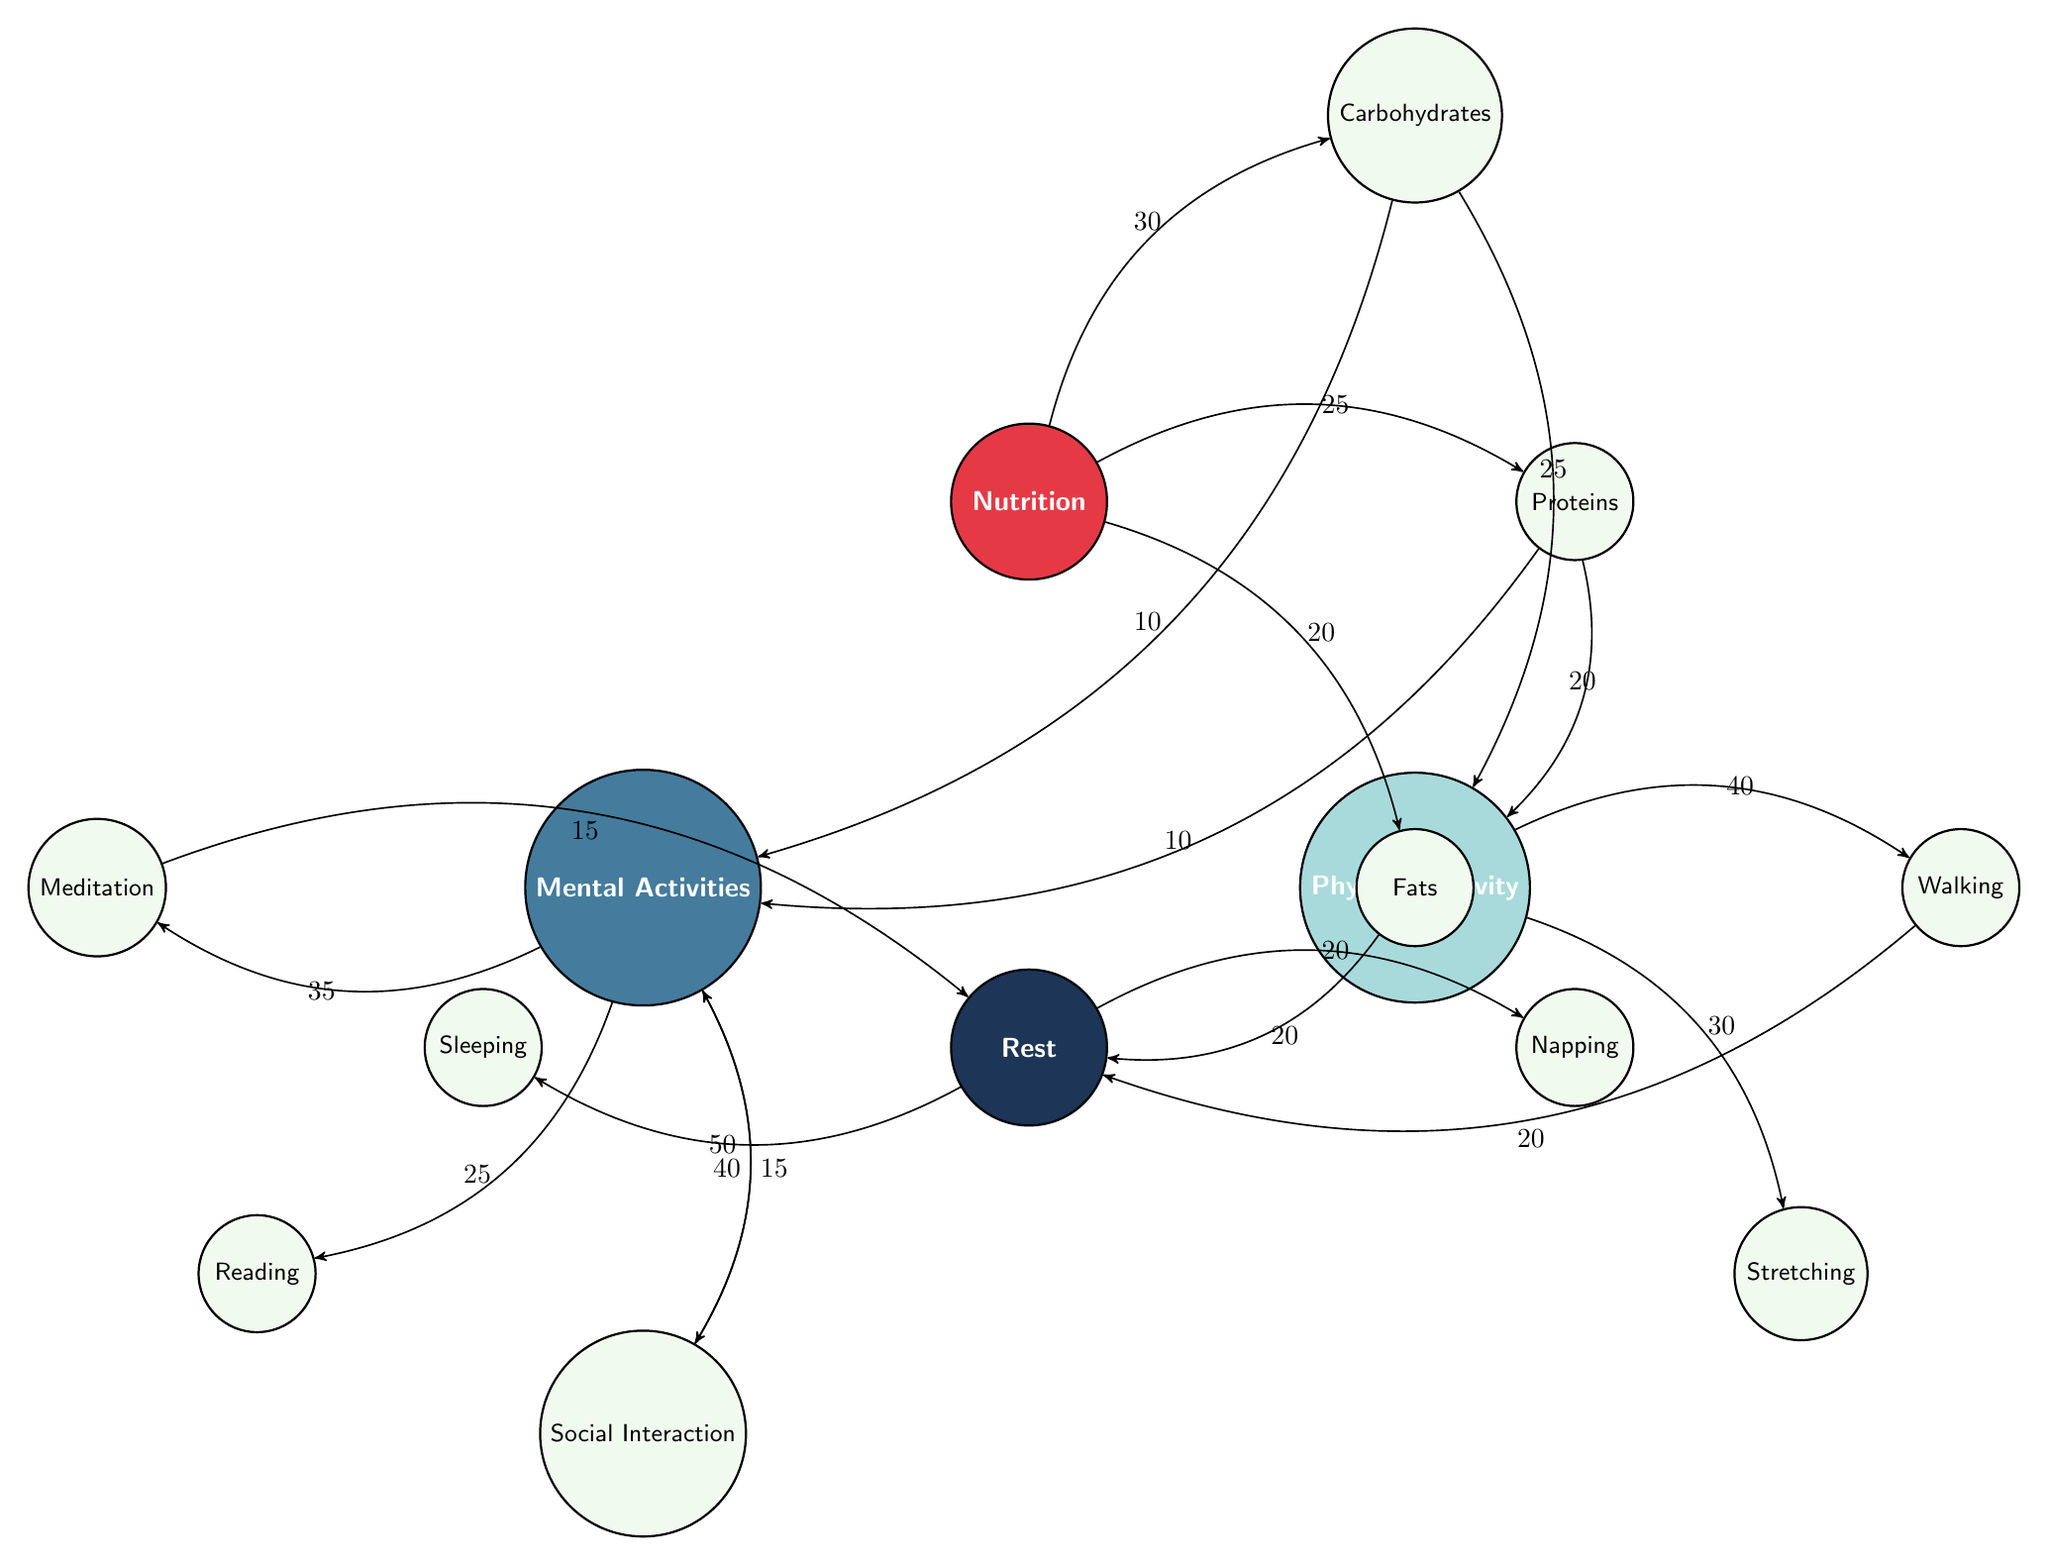What is the value connecting Nutrition to Carbohydrates? The diagram shows an edge between the Nutrition node and the Carbohydrates node, with a value of 30 labeled on the edge.
Answer: 30 How many nodes are in the diagram? By counting the nodes listed on the diagram, there are a total of 12 nodes: Nutrition, Physical Activity, Mental Activities, Rest, Carbohydrates, Proteins, Fats, Walking, Stretching, Meditation, Reading, Social Interaction, Sleeping, and Napping.
Answer: 12 What is the energy value associated with Mental Activities to Social Interaction? The edge between the Mental Activities node and the Social Interaction node has a value of 40 labeled on it.
Answer: 40 Which physical activity has the highest energy value linked from Physical Activity? The edge from Physical Activity to Walking has the highest value of 40, indicating it uses the most energy compared to the other linked activities.
Answer: Walking How much energy do Proteins provide to Physical Activity? The diagram shows an edge from Proteins to Physical Activity with a value of 20, indicating the amount of energy used.
Answer: 20 What is the total energy usage from Rest activities? The total energy from the Rest node can be calculated by summing the values of the edges to Sleeping (50) and Napping (20), giving a total of 70 energy units.
Answer: 70 What is the relationship between Carbohydrates and Mental Activities? The edges connecting Carbohydrates to Mental Activities show values of 10 in each direction, indicating that Carbohydrates provide some energy to Mental Activities, but the flow is not as strong as it is to Physical Activity.
Answer: 10 Which activity has the least energy connection to Rest? The lowest value connected to Rest is from Napping, with a value of 20, indicating it contributes the least energy.
Answer: Napping Which energy source is linked to the most activities based on the diagram? By analyzing the connections, Nutrition is linked to three activities: Carbohydrates, Proteins, and Fats, indicating it has the most outgoing connections.
Answer: Nutrition 